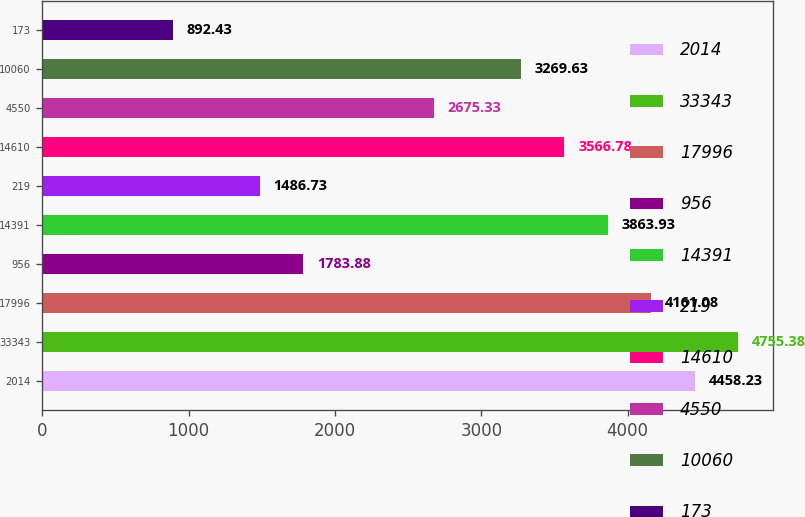<chart> <loc_0><loc_0><loc_500><loc_500><bar_chart><fcel>2014<fcel>33343<fcel>17996<fcel>956<fcel>14391<fcel>219<fcel>14610<fcel>4550<fcel>10060<fcel>173<nl><fcel>4458.23<fcel>4755.38<fcel>4161.08<fcel>1783.88<fcel>3863.93<fcel>1486.73<fcel>3566.78<fcel>2675.33<fcel>3269.63<fcel>892.43<nl></chart> 